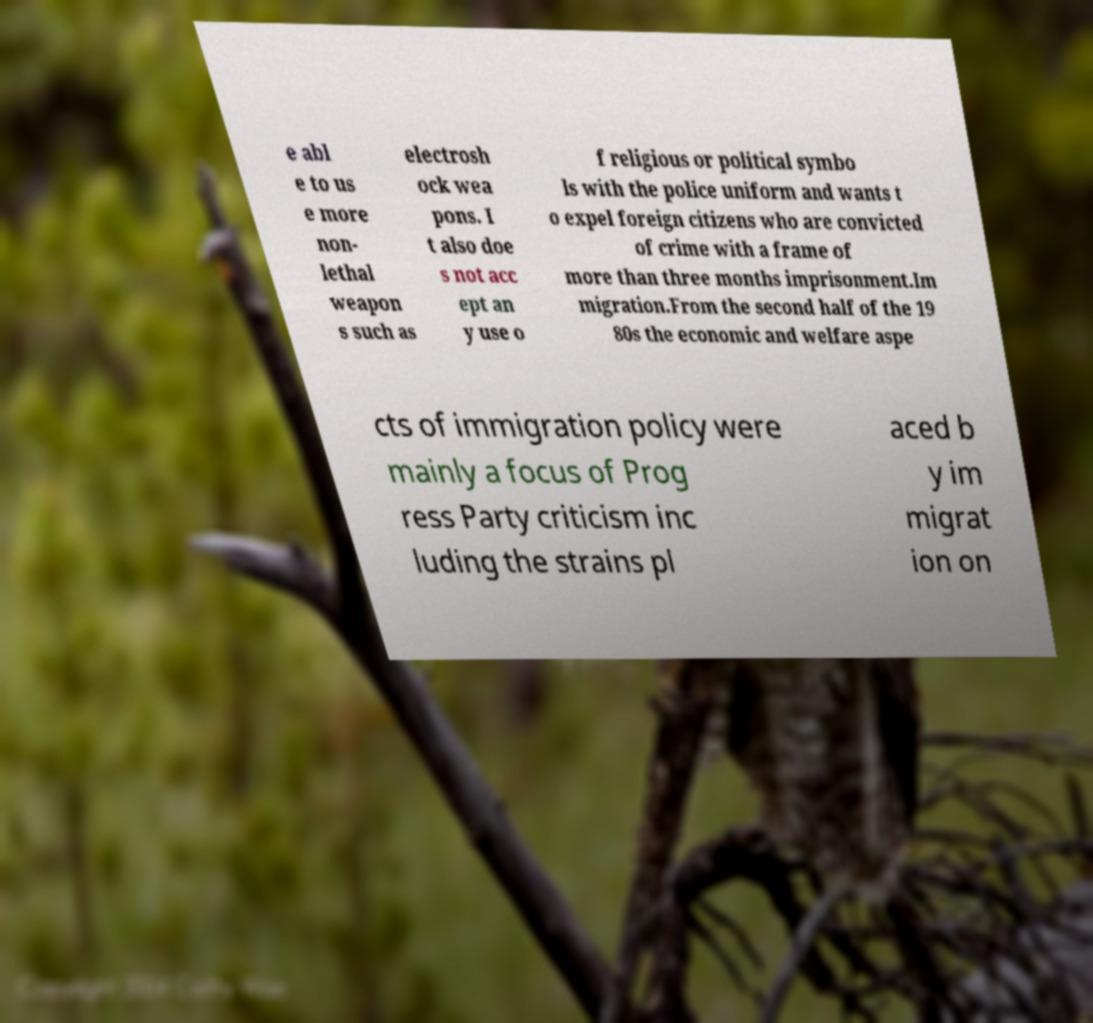Could you assist in decoding the text presented in this image and type it out clearly? e abl e to us e more non- lethal weapon s such as electrosh ock wea pons. I t also doe s not acc ept an y use o f religious or political symbo ls with the police uniform and wants t o expel foreign citizens who are convicted of crime with a frame of more than three months imprisonment.Im migration.From the second half of the 19 80s the economic and welfare aspe cts of immigration policy were mainly a focus of Prog ress Party criticism inc luding the strains pl aced b y im migrat ion on 